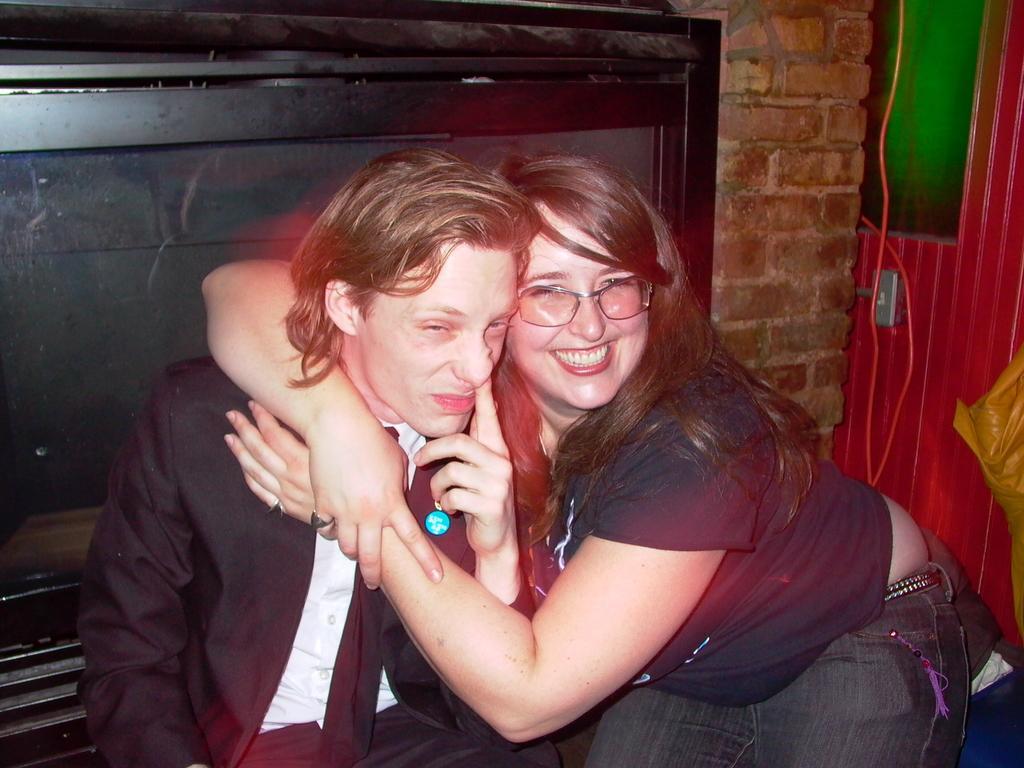Describe this image in one or two sentences. In this image we can see two persons, one T. V attached to the wall, some objects are on the surface, one wire and one red door. 